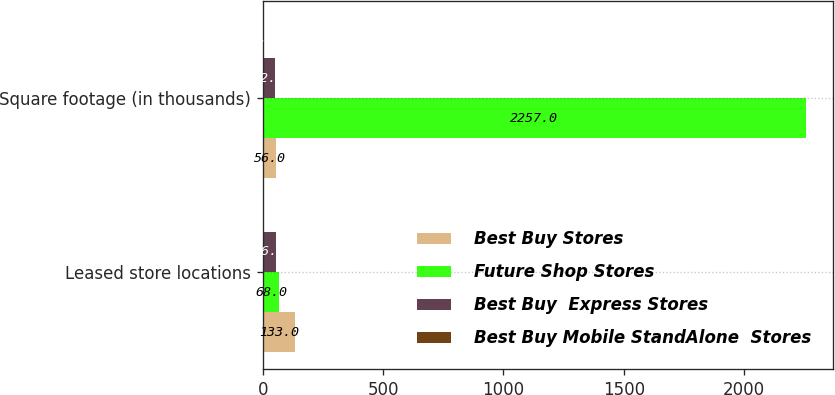Convert chart. <chart><loc_0><loc_0><loc_500><loc_500><stacked_bar_chart><ecel><fcel>Leased store locations<fcel>Square footage (in thousands)<nl><fcel>Best Buy Stores<fcel>133<fcel>56<nl><fcel>Future Shop Stores<fcel>68<fcel>2257<nl><fcel>Best Buy  Express Stores<fcel>56<fcel>52<nl><fcel>Best Buy Mobile StandAlone  Stores<fcel>5<fcel>7<nl></chart> 